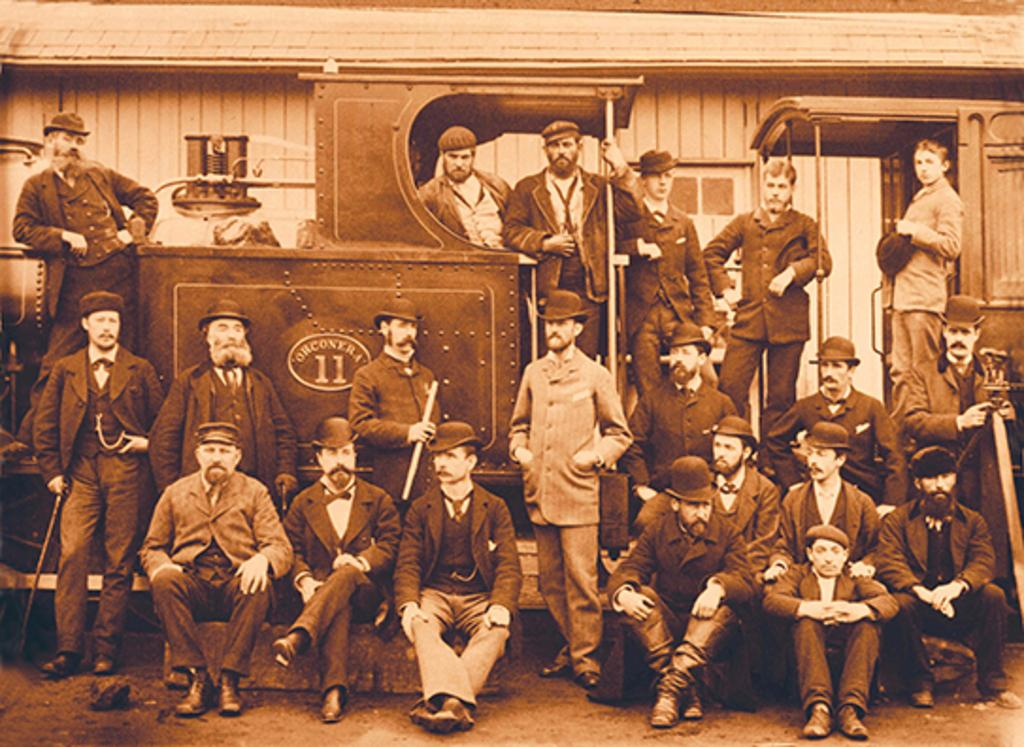What is depicted in the image? There is a photocopy of people in the image. What are some of the people in the photocopy doing? Some people in the photocopy are holding objects. What can be seen below the photocopy in the image? The ground is visible in the image. What can be seen in the distance in the image? There is a train in the background of the image. How many legs are visible on the people in the image? The image is a photocopy, so it does not show the actual legs of the people; it only shows a two-dimensional representation of them. 